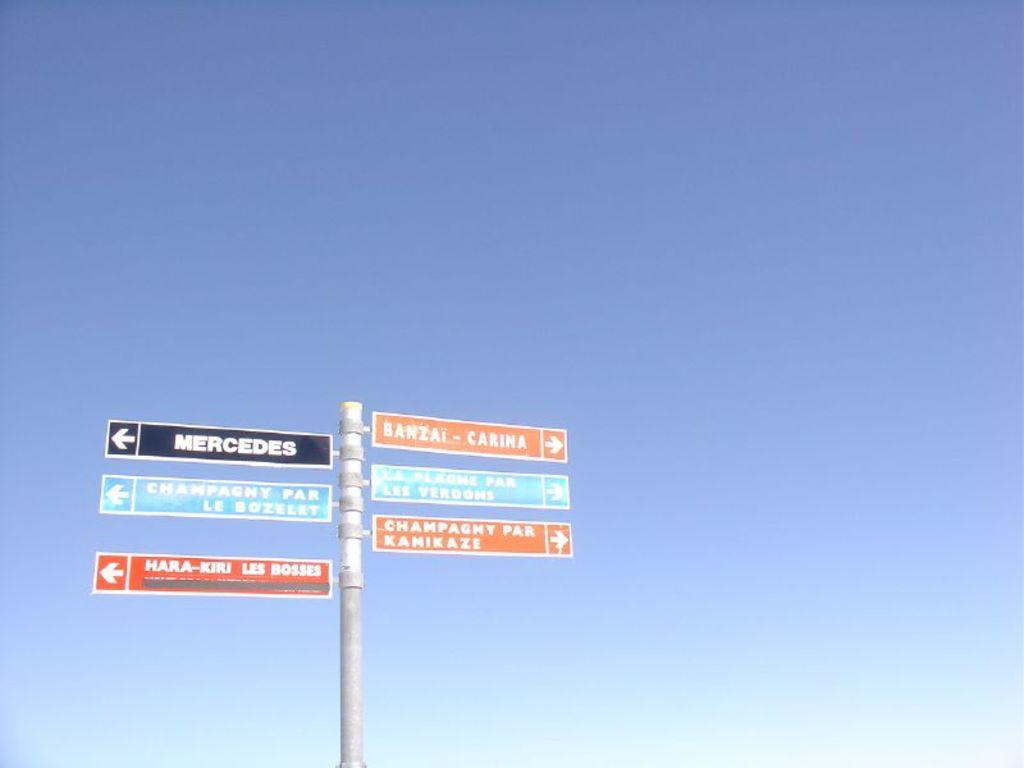What is one of the locations to the left that the sign mentions?
Give a very brief answer. Mercedes. What is on the sign on the top right?
Ensure brevity in your answer.  Banzai - carina. 